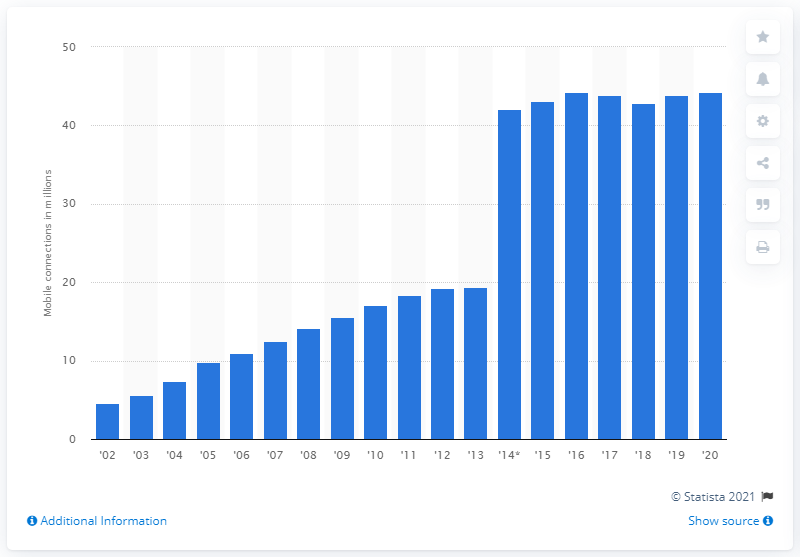Give some essential details in this illustration. As of 2020, there were 44.28 million mobile connections in Telefonica's network. 